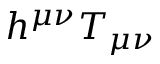Convert formula to latex. <formula><loc_0><loc_0><loc_500><loc_500>h ^ { \mu \nu } T _ { \mu \nu }</formula> 